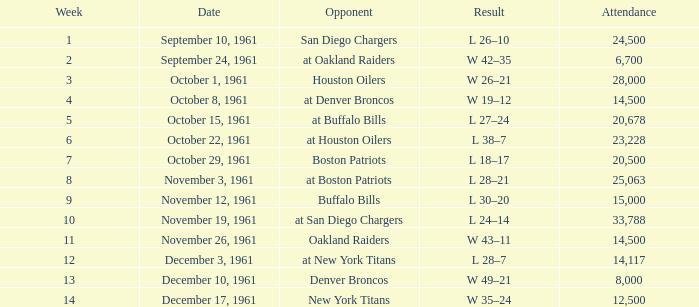What is the low attendance rate against buffalo bills? 15000.0. 